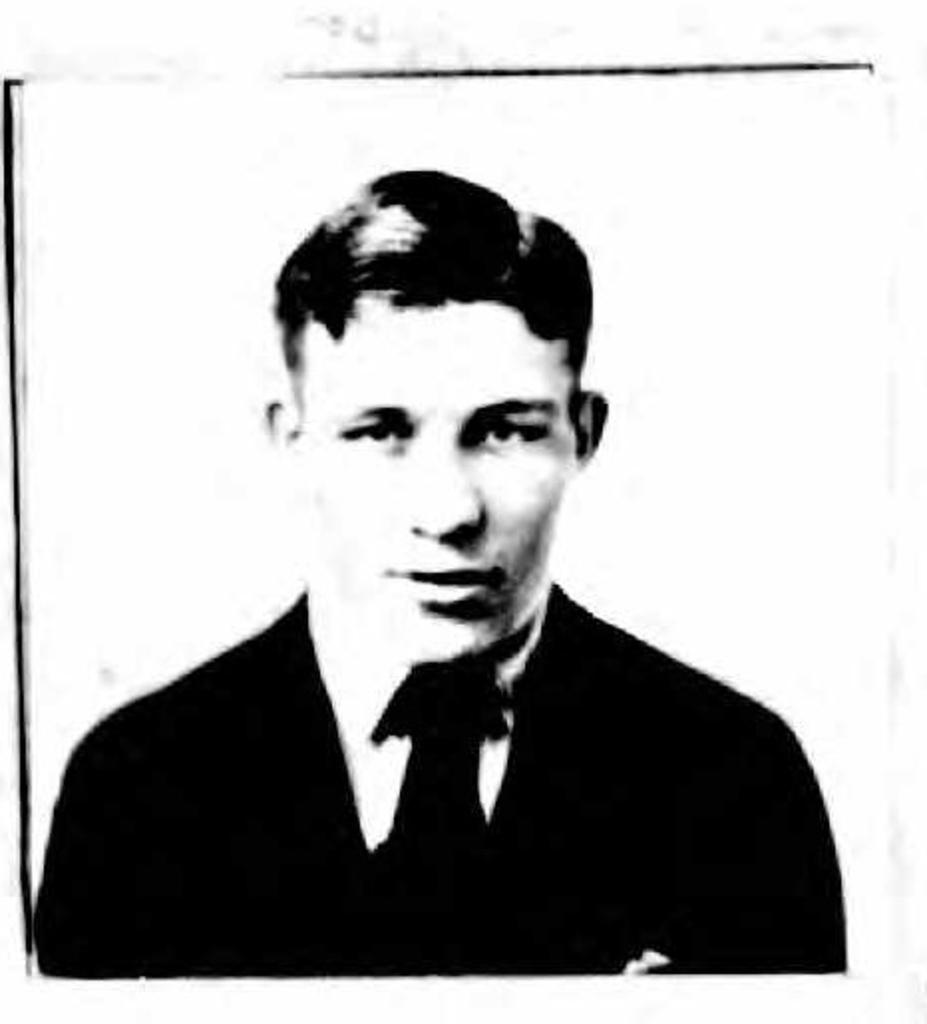What is the main subject of the image? The main subject of the image is a person. What is the color scheme of the photograph? The photograph is in black and white. What type of tank is visible in the background of the photograph? There is no tank present in the photograph; it is a black and white image of a person. Is the person made of wax in the photograph? There is no indication in the photograph that the person is made of wax. 